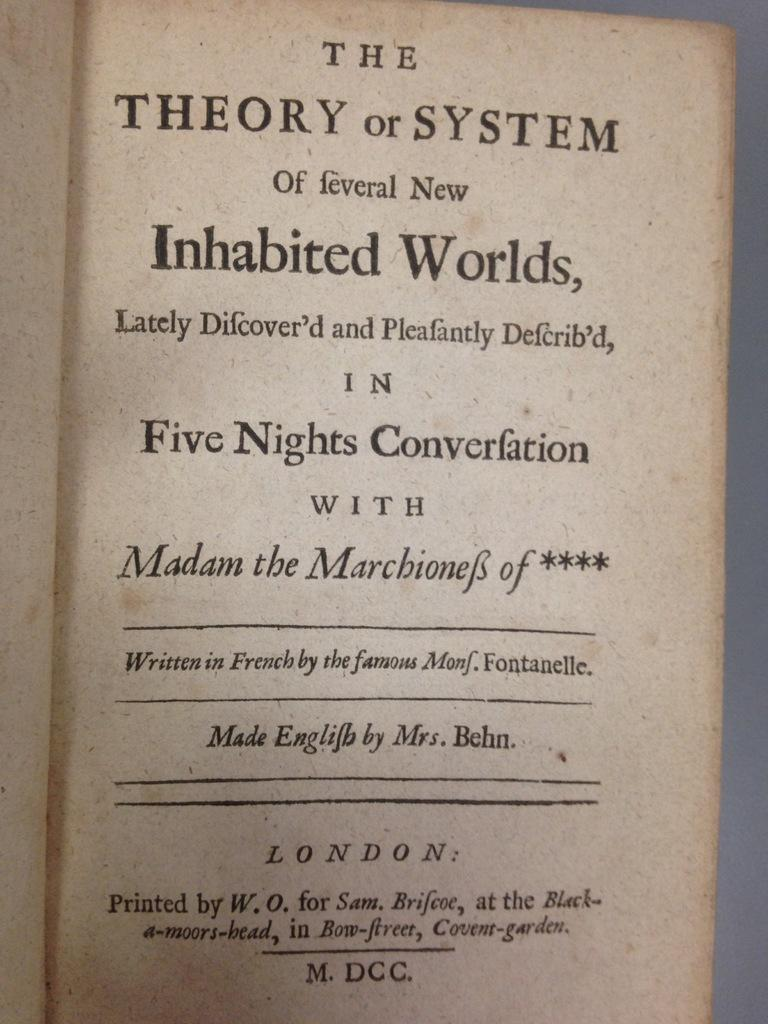<image>
Describe the image concisely. A book about Inhabited Worlds was "made in English" by Mrs. Behn. 